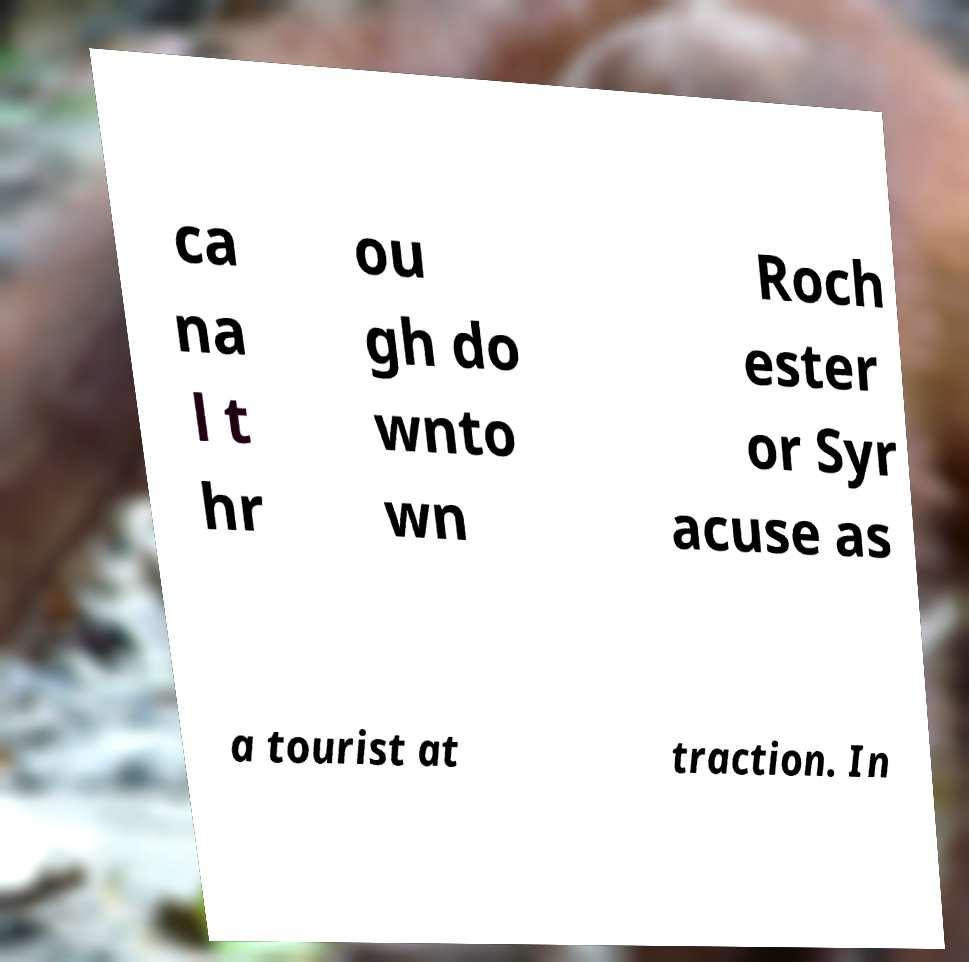Can you read and provide the text displayed in the image?This photo seems to have some interesting text. Can you extract and type it out for me? ca na l t hr ou gh do wnto wn Roch ester or Syr acuse as a tourist at traction. In 